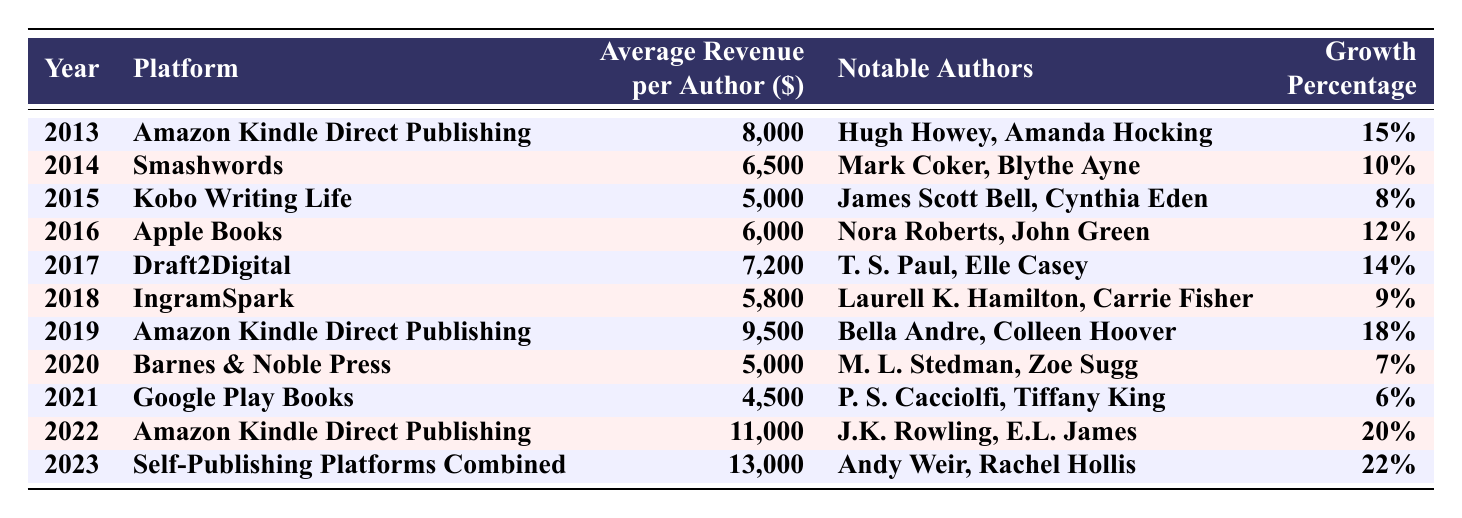What was the average revenue per author in 2013? In 2013, the table shows that the average revenue per author on Amazon Kindle Direct Publishing was 8,000.
Answer: 8,000 Which platform had the highest average revenue per author in 2022? The table indicates that in 2022, Amazon Kindle Direct Publishing had the highest average revenue per author at 11,000.
Answer: 11,000 What is the growth percentage of self-published authors on Smashwords from 2014? According to the table, the growth percentage of self-published authors on Smashwords in 2014 was 10%.
Answer: 10% What was the revenue growth percentage from 2013 to 2014 for Amazon Kindle Direct Publishing? The average revenue per author in 2013 was 8,000, growing to 6,500 in 2014 (which is a decrease), so the growth percentage cannot be calculated for this span as it actually represents a decline.
Answer: No growth How much did the average revenue per author increase from 2019 to 2022 on Amazon Kindle Direct Publishing? In 2019 the average revenue was 9,500, and in 2022 it was 11,000. The increase is 11,000 - 9,500 = 1,500.
Answer: 1,500 What is the average revenue of self-published authors across all platforms in 2023? In 2023, the table shows an average revenue per author of 13,000 across self-publishing platforms combined.
Answer: 13,000 Which notable author appeared on the KDP platform in 2019? The table lists Bella Andre and Colleen Hoover as notable authors for Amazon Kindle Direct Publishing in 2019.
Answer: Bella Andre, Colleen Hoover Was there any platform that had a revenue lower than 5,000 in 2021? The table shows that Google Play Books had an average revenue per author of 4,500 in 2021, which is indeed lower than 5,000.
Answer: Yes Which two years saw the highest growth percentages for self-published authors? According to the table, the highest growth percentages were in 2022 (20%) and 2023 (22%). Combining these indicates 22% was the highest followed by 20%.
Answer: 2022 and 2023 What was the total average revenue for self-published authors in 2015 and 2016? In 2015, the average was 5,000, and in 2016 it was 6,000. The total is 5,000 + 6,000 = 11,000.
Answer: 11,000 